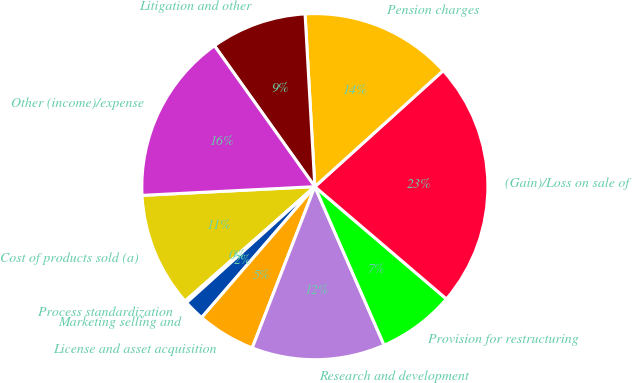Convert chart to OTSL. <chart><loc_0><loc_0><loc_500><loc_500><pie_chart><fcel>Cost of products sold (a)<fcel>Process standardization<fcel>Marketing selling and<fcel>License and asset acquisition<fcel>Research and development<fcel>Provision for restructuring<fcel>(Gain)/Loss on sale of<fcel>Pension charges<fcel>Litigation and other<fcel>Other (income)/expense<nl><fcel>10.7%<fcel>0.2%<fcel>1.95%<fcel>5.45%<fcel>12.45%<fcel>7.2%<fcel>22.94%<fcel>14.2%<fcel>8.95%<fcel>15.95%<nl></chart> 